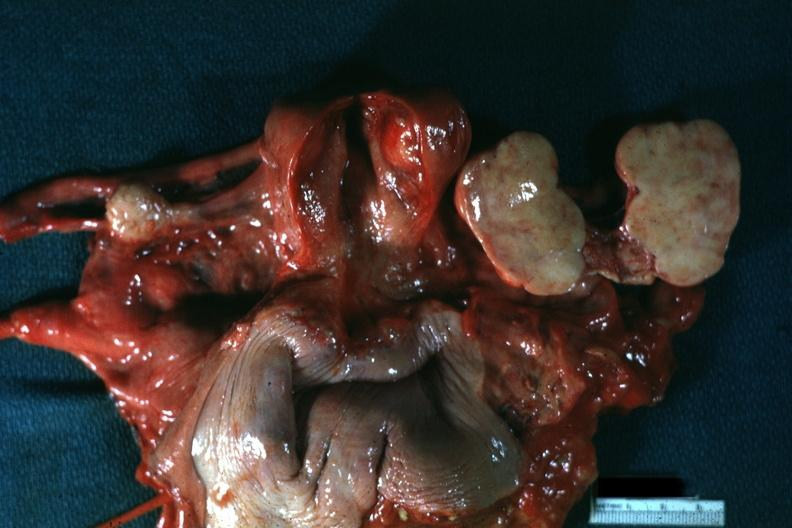does this image show all pelvic organs tumor mass opened like a book typical for this lesion?
Answer the question using a single word or phrase. Yes 